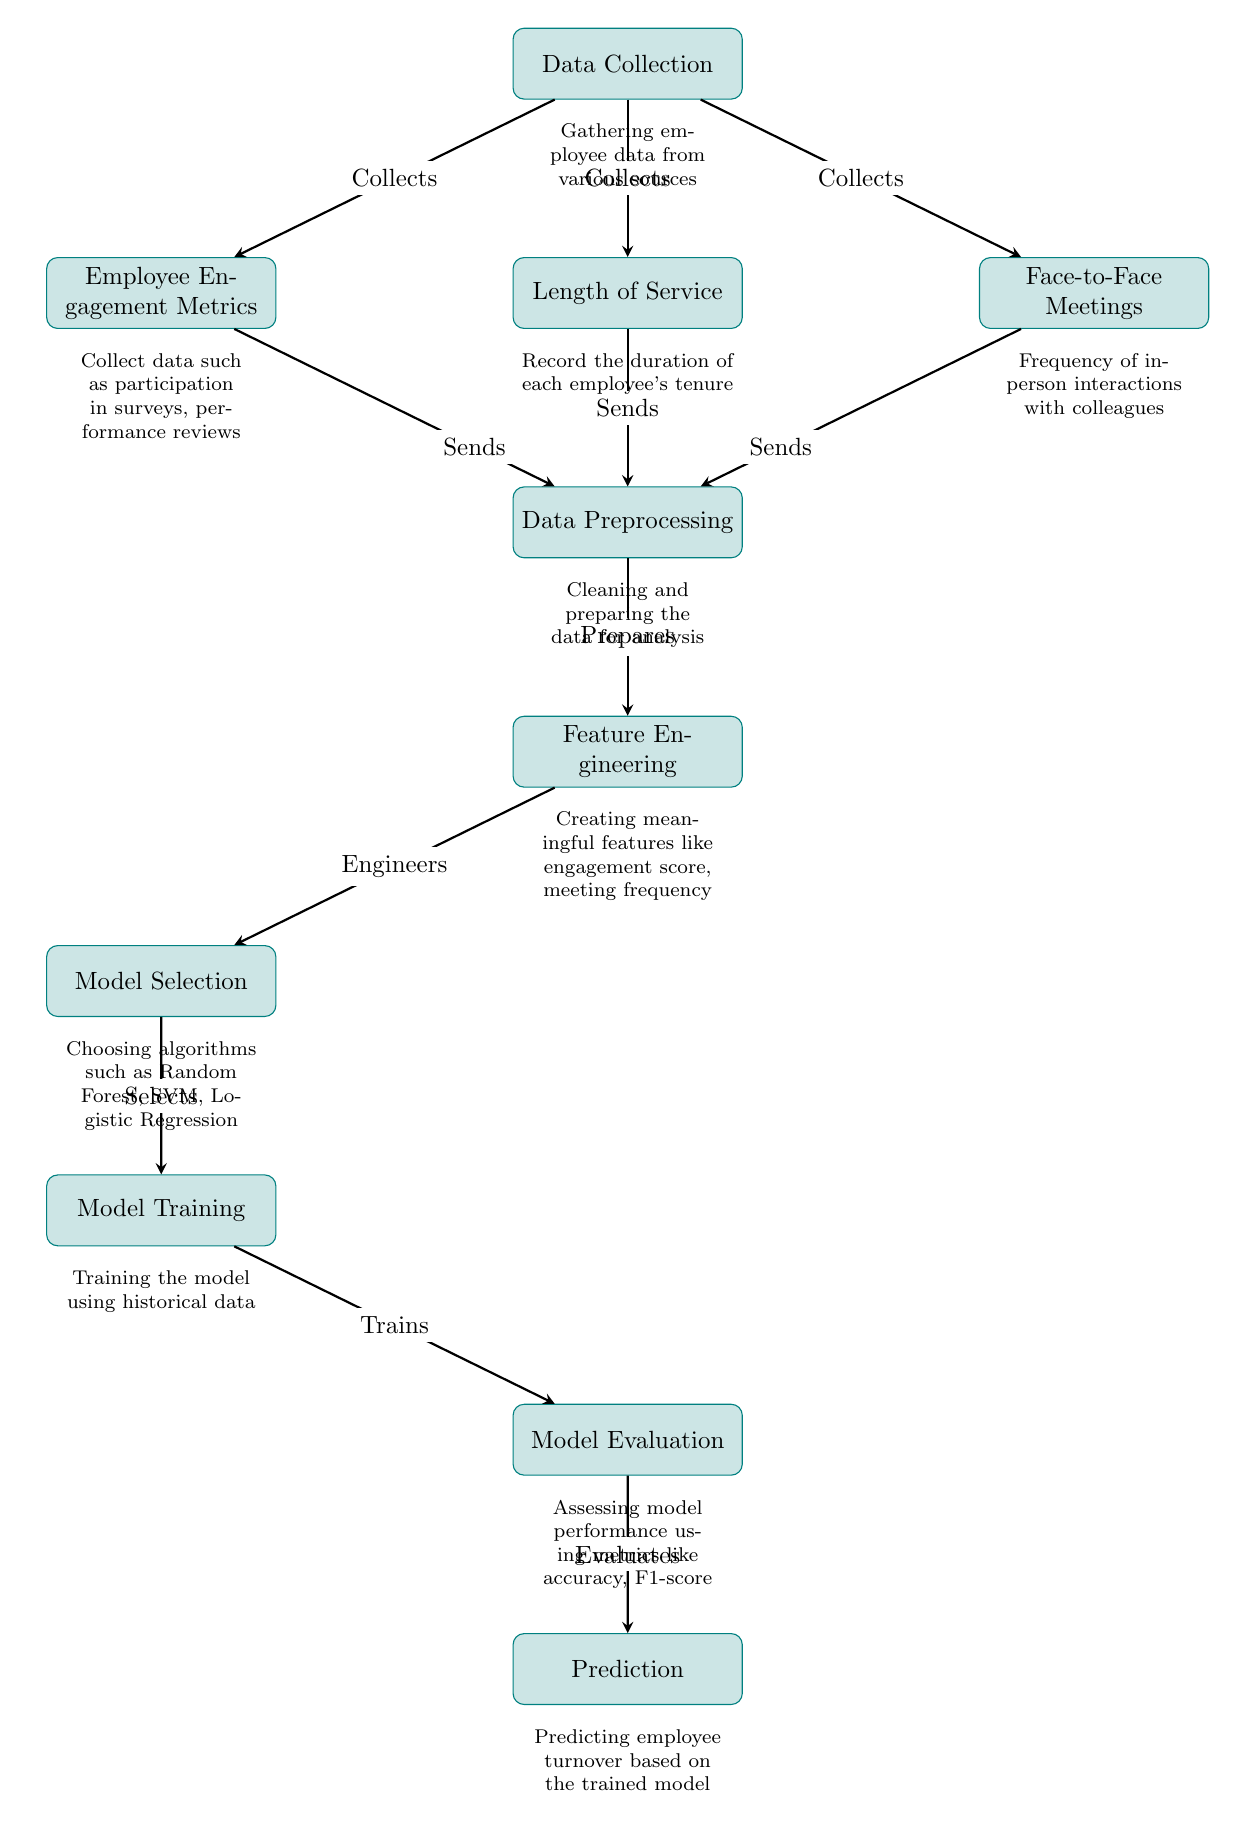What are the three main data sources in the flow? The diagram shows three main sources for data collection: Employee Engagement Metrics, Length of Service, and Face-to-Face Meetings.
Answer: Employee Engagement Metrics, Length of Service, Face-to-Face Meetings What process follows Data Preprocessing? According to the diagram, after Data Preprocessing, the next step is Feature Engineering.
Answer: Feature Engineering How many processes are involved in this diagram? By counting the distinct processes in the diagram, we find a total of six: Data Collection, Data Preprocessing, Feature Engineering, Model Selection, Model Training, and Model Evaluation.
Answer: Six What is sent from Employee Engagement Metrics to Data Preprocessing? The diagram indicates that Employee Engagement Metrics sends data to Data Preprocessing after collection.
Answer: Sends What relationships exist between Model Selection and Model Training? The diagram shows that Model Selection selects algorithms which then leads into Model Training. Therefore, Model Selection directly influences Model Training.
Answer: Selects Which model evaluation metric is mentioned in the diagram? The diagram specifies the use of accuracy and F1-score as metrics for model evaluation.
Answer: Accuracy, F1-score What is the final output of the diagram? The ultimate output predicted by the diagram flows from Model Evaluation, resulting in the Prediction of employee turnover.
Answer: Prediction What prepares data after feature engineering? According to the flow of the diagram, Feature Engineering prepares data for Model Selection following the preprocessing step.
Answer: Prepares 